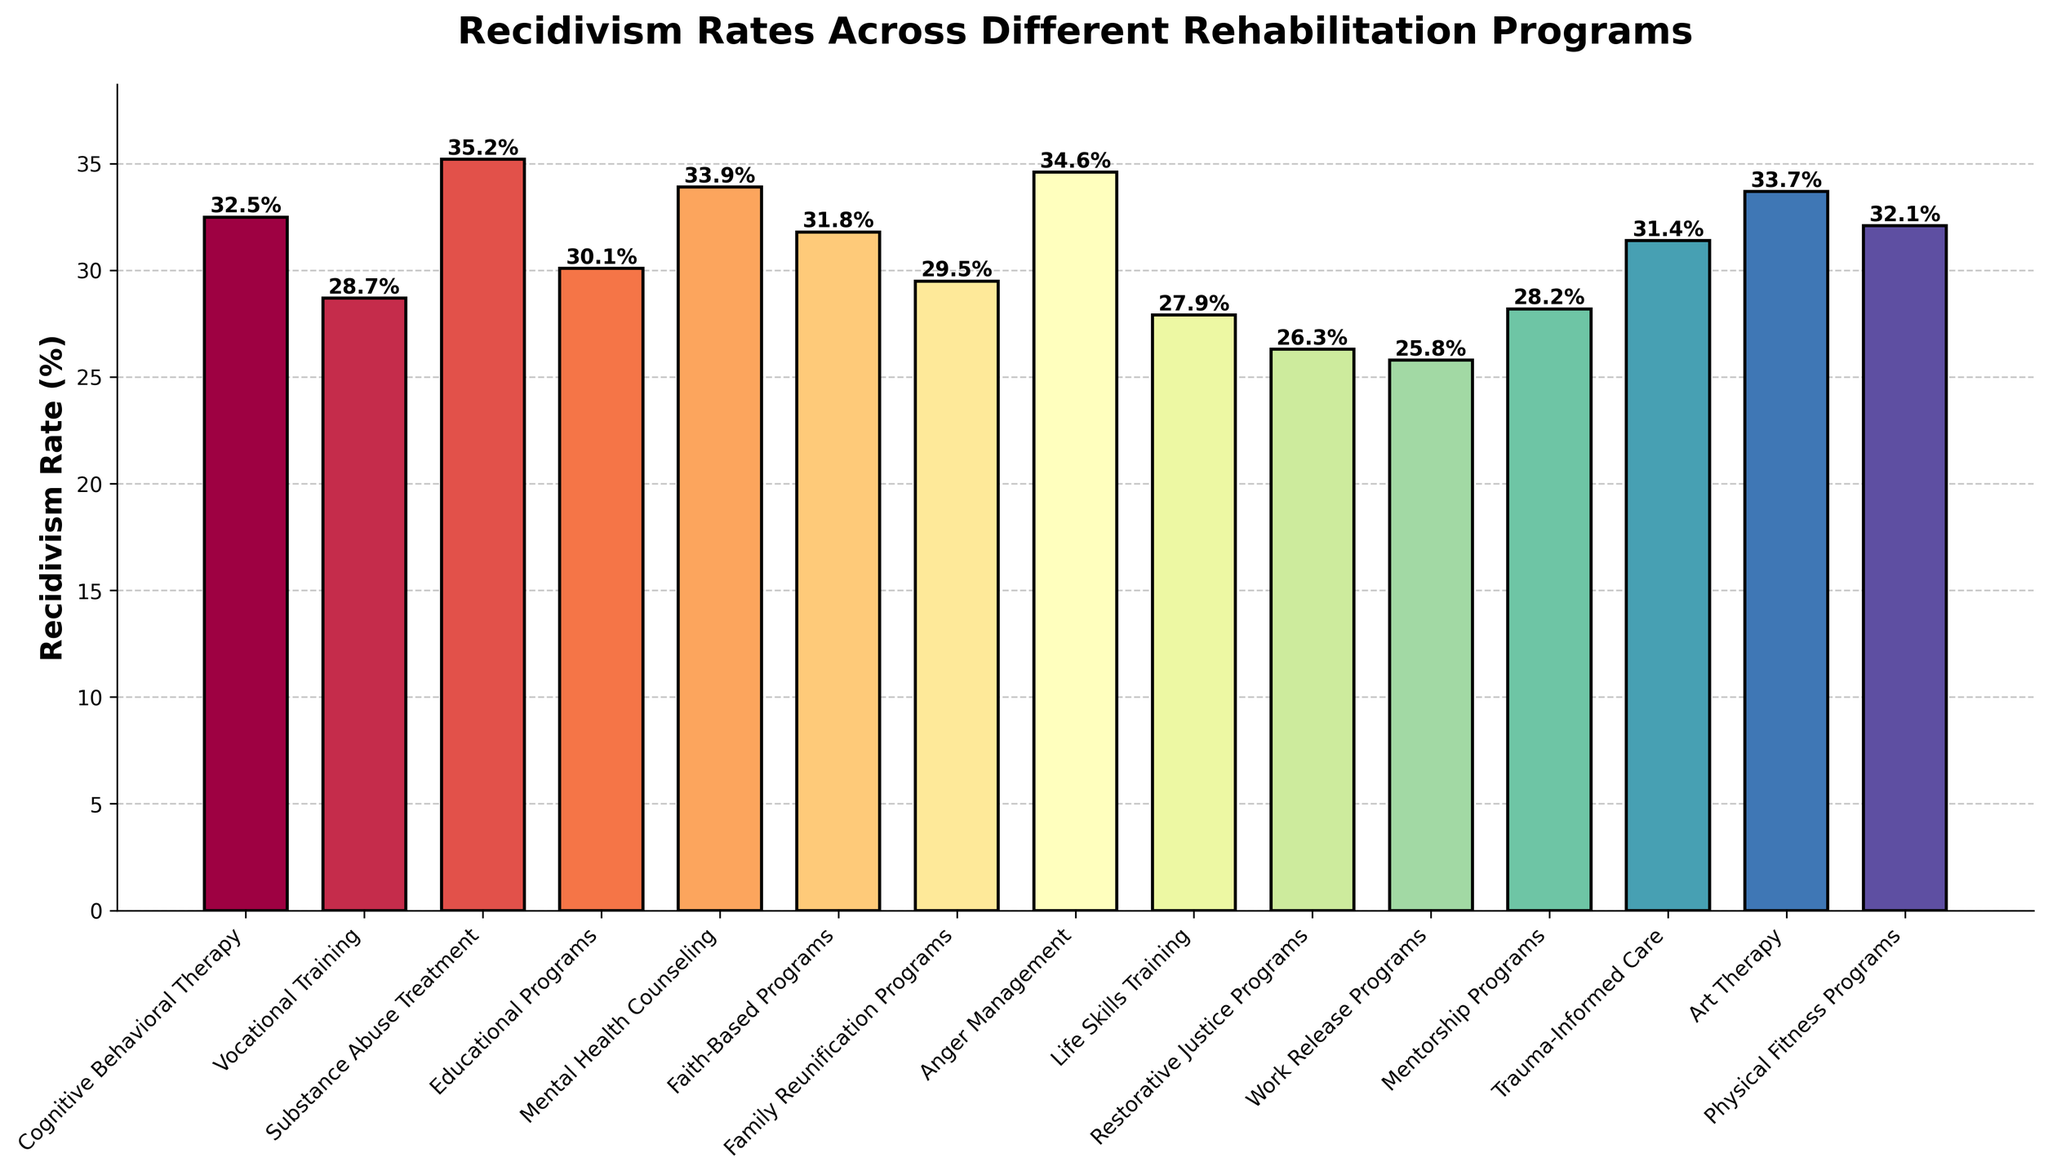What is the recidivism rate for the Work Release Programs? Identify the bar labeled "Work Release Programs", then look at the height of the bar to find the recidivism rate. The bar shows a height labeled 25.8%.
Answer: 25.8% Which rehabilitation program has the highest recidivism rate? Identify the tallest bar among all bars in the figure. The tallest bar represents the Substance Abuse Treatment program, with a recidivism rate of 35.2%.
Answer: Substance Abuse Treatment How much lower is the recidivism rate for the Life Skills Training compared to the Anger Management program? Find the bars for Life Skills Training (27.9%) and Anger Management (34.6%), then subtract the former from the latter: 34.6% - 27.9% = 6.7%.
Answer: 6.7% What is the average recidivism rate of the following programs: Cognitive Behavioral Therapy, Vocational Training, and Substance Abuse Treatment? Find the recidivism rates of these programs: Cognitive Behavioral Therapy (32.5%), Vocational Training (28.7%), Substance Abuse Treatment (35.2%). Calculate the average: (32.5 + 28.7 + 35.2) / 3 = 96.4 / 3 = 32.1%.
Answer: 32.1% Which program has a lower recidivism rate, Mental Health Counseling or Faith-Based Programs? Compare the heights of the bars for Mental Health Counseling (33.9%) and Faith-Based Programs (31.8%). The Faith-Based Programs have a lower rate.
Answer: Faith-Based Programs What is the combined recidivism rate of Educational Programs and Family Reunification Programs? Sum the recidivism rates for Educational Programs (30.1%) and Family Reunification Programs (29.5%): 30.1% + 29.5% = 59.6%.
Answer: 59.6% Is the recidivism rate for Art Therapy higher or lower than the average rate of all programs? First, calculate the average rate of all programs by summing their rates and dividing by the number of programs. Then compare it to Art Therapy (33.7%). Sum = 469.7%, Number of Programs = 15, Average = 469.7 / 15 = 31.3%, thus Art Therapy (33.7%) is higher.
Answer: Higher What is the median recidivism rate of the listed programs? Order all recidivism rates and find the middle value. In ascending order: 25.8, 26.3, 27.9, 28.2, 28.7, 29.5, 30.1, 31.4, 31.8, 32.1, 32.5, 33.7, 33.9, 34.6, 35.2. The middle value (8th value) is 31.4%.
Answer: 31.4% By how much does the recidivism rate of Restorative Justice Programs differ from the overall average rate? Calculate the overall average rate (31.3%). The difference from Restorative Justice Programs (26.3%) is 31.3% - 26.3% = 5.0%.
Answer: 5.0% 